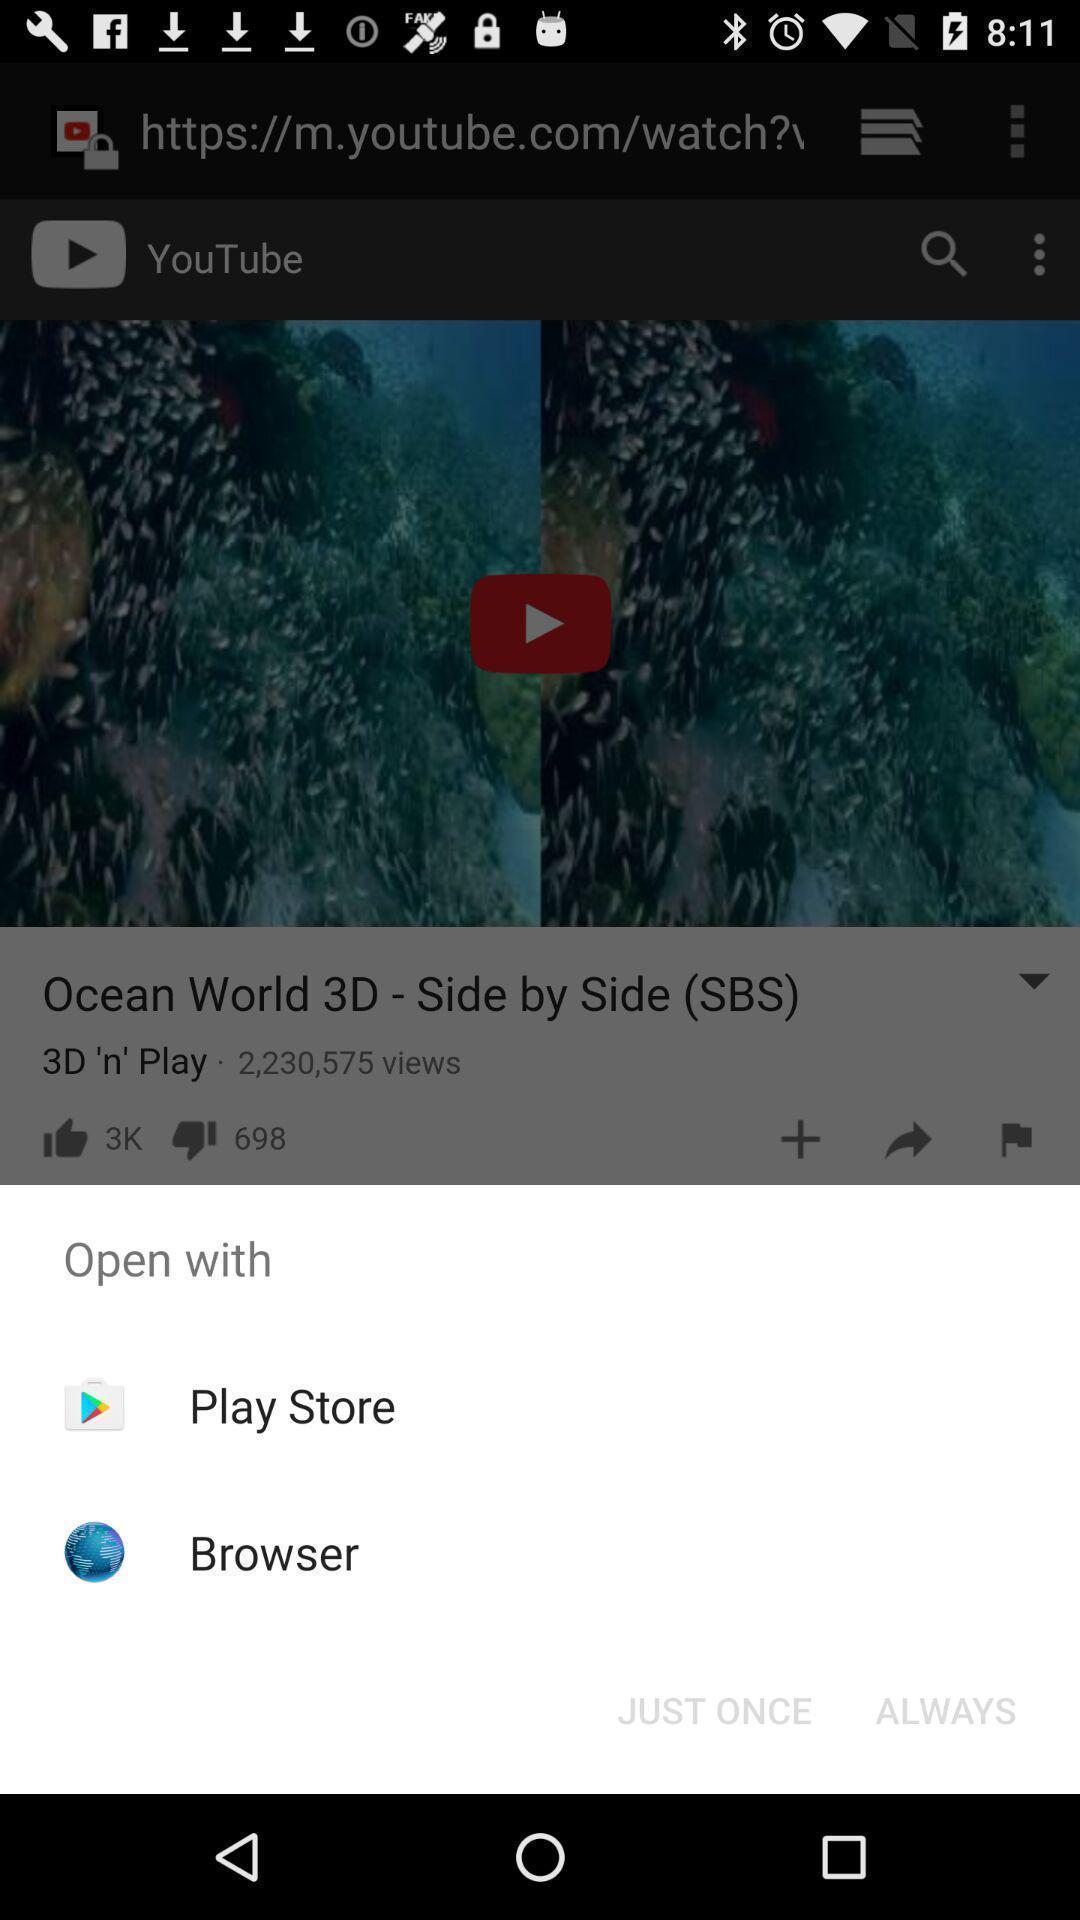Describe the content in this image. Pop-up to open an application with multiple options. 